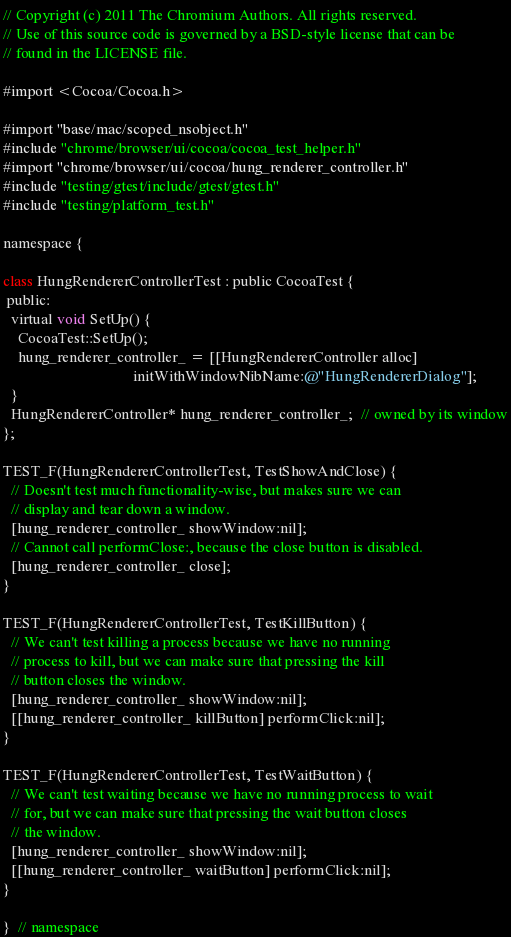Convert code to text. <code><loc_0><loc_0><loc_500><loc_500><_ObjectiveC_>// Copyright (c) 2011 The Chromium Authors. All rights reserved.
// Use of this source code is governed by a BSD-style license that can be
// found in the LICENSE file.

#import <Cocoa/Cocoa.h>

#import "base/mac/scoped_nsobject.h"
#include "chrome/browser/ui/cocoa/cocoa_test_helper.h"
#import "chrome/browser/ui/cocoa/hung_renderer_controller.h"
#include "testing/gtest/include/gtest/gtest.h"
#include "testing/platform_test.h"

namespace {

class HungRendererControllerTest : public CocoaTest {
 public:
  virtual void SetUp() {
    CocoaTest::SetUp();
    hung_renderer_controller_ = [[HungRendererController alloc]
                                  initWithWindowNibName:@"HungRendererDialog"];
  }
  HungRendererController* hung_renderer_controller_;  // owned by its window
};

TEST_F(HungRendererControllerTest, TestShowAndClose) {
  // Doesn't test much functionality-wise, but makes sure we can
  // display and tear down a window.
  [hung_renderer_controller_ showWindow:nil];
  // Cannot call performClose:, because the close button is disabled.
  [hung_renderer_controller_ close];
}

TEST_F(HungRendererControllerTest, TestKillButton) {
  // We can't test killing a process because we have no running
  // process to kill, but we can make sure that pressing the kill
  // button closes the window.
  [hung_renderer_controller_ showWindow:nil];
  [[hung_renderer_controller_ killButton] performClick:nil];
}

TEST_F(HungRendererControllerTest, TestWaitButton) {
  // We can't test waiting because we have no running process to wait
  // for, but we can make sure that pressing the wait button closes
  // the window.
  [hung_renderer_controller_ showWindow:nil];
  [[hung_renderer_controller_ waitButton] performClick:nil];
}

}  // namespace

</code> 